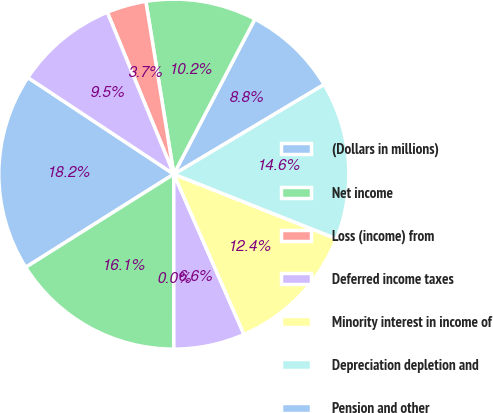<chart> <loc_0><loc_0><loc_500><loc_500><pie_chart><fcel>(Dollars in millions)<fcel>Net income<fcel>Loss (income) from<fcel>Deferred income taxes<fcel>Minority interest in income of<fcel>Depreciation depletion and<fcel>Pension and other<fcel>Exploratory dry well costs and<fcel>Net gains on disposal of<fcel>Changes in the fair value of<nl><fcel>18.24%<fcel>16.05%<fcel>0.01%<fcel>6.57%<fcel>12.41%<fcel>14.59%<fcel>8.76%<fcel>10.22%<fcel>3.65%<fcel>9.49%<nl></chart> 